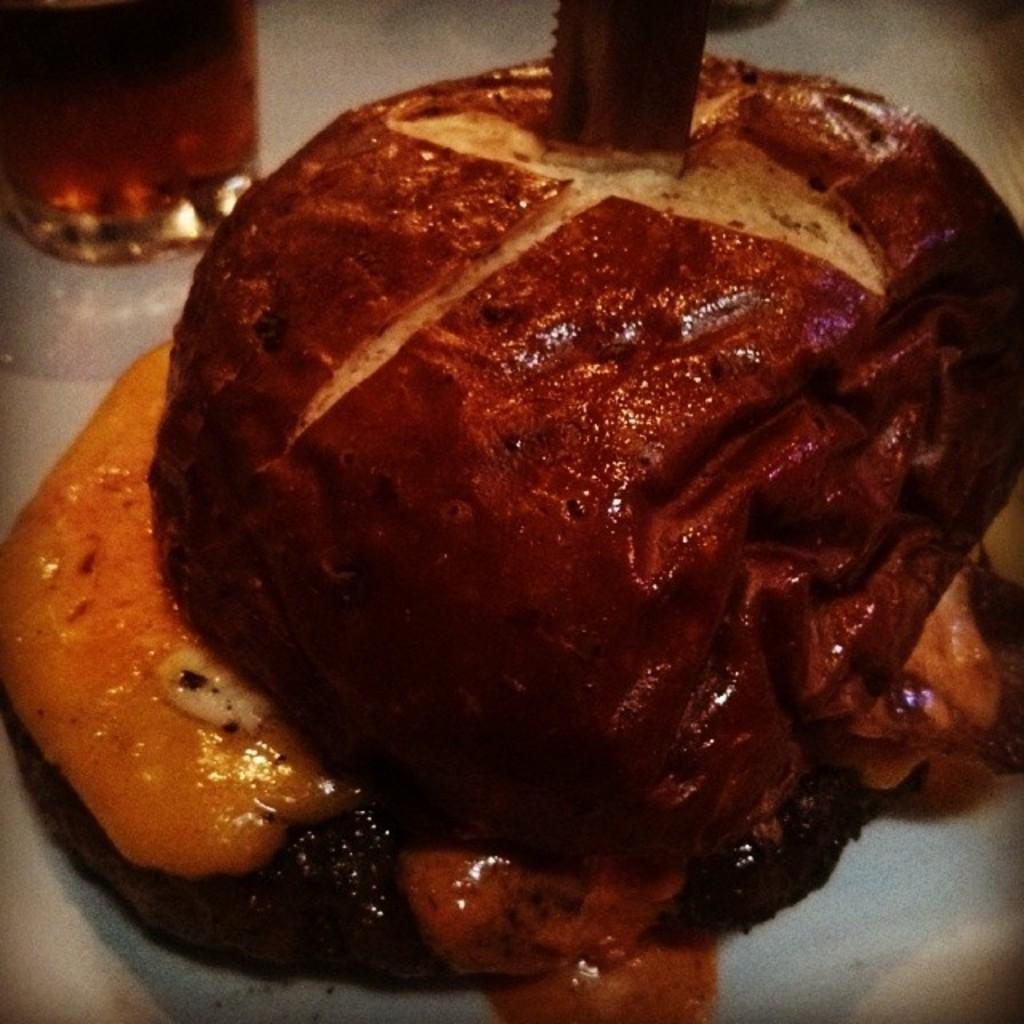What is the main subject of the image? The main subject of the image is food. Where is the food located in the image? The food is on an object. What can be seen at the top of the image? There is a glass and a knife visible at the top of the image. How many tickets are visible in the image? There are no tickets present in the image. What type of tooth is shown in the image? There is no tooth present in the image. 